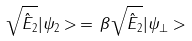Convert formula to latex. <formula><loc_0><loc_0><loc_500><loc_500>\sqrt { \hat { E } _ { 2 } } | \psi _ { 2 } > \, = \, \beta \sqrt { \hat { E } _ { 2 } } | \psi _ { \bot } ></formula> 